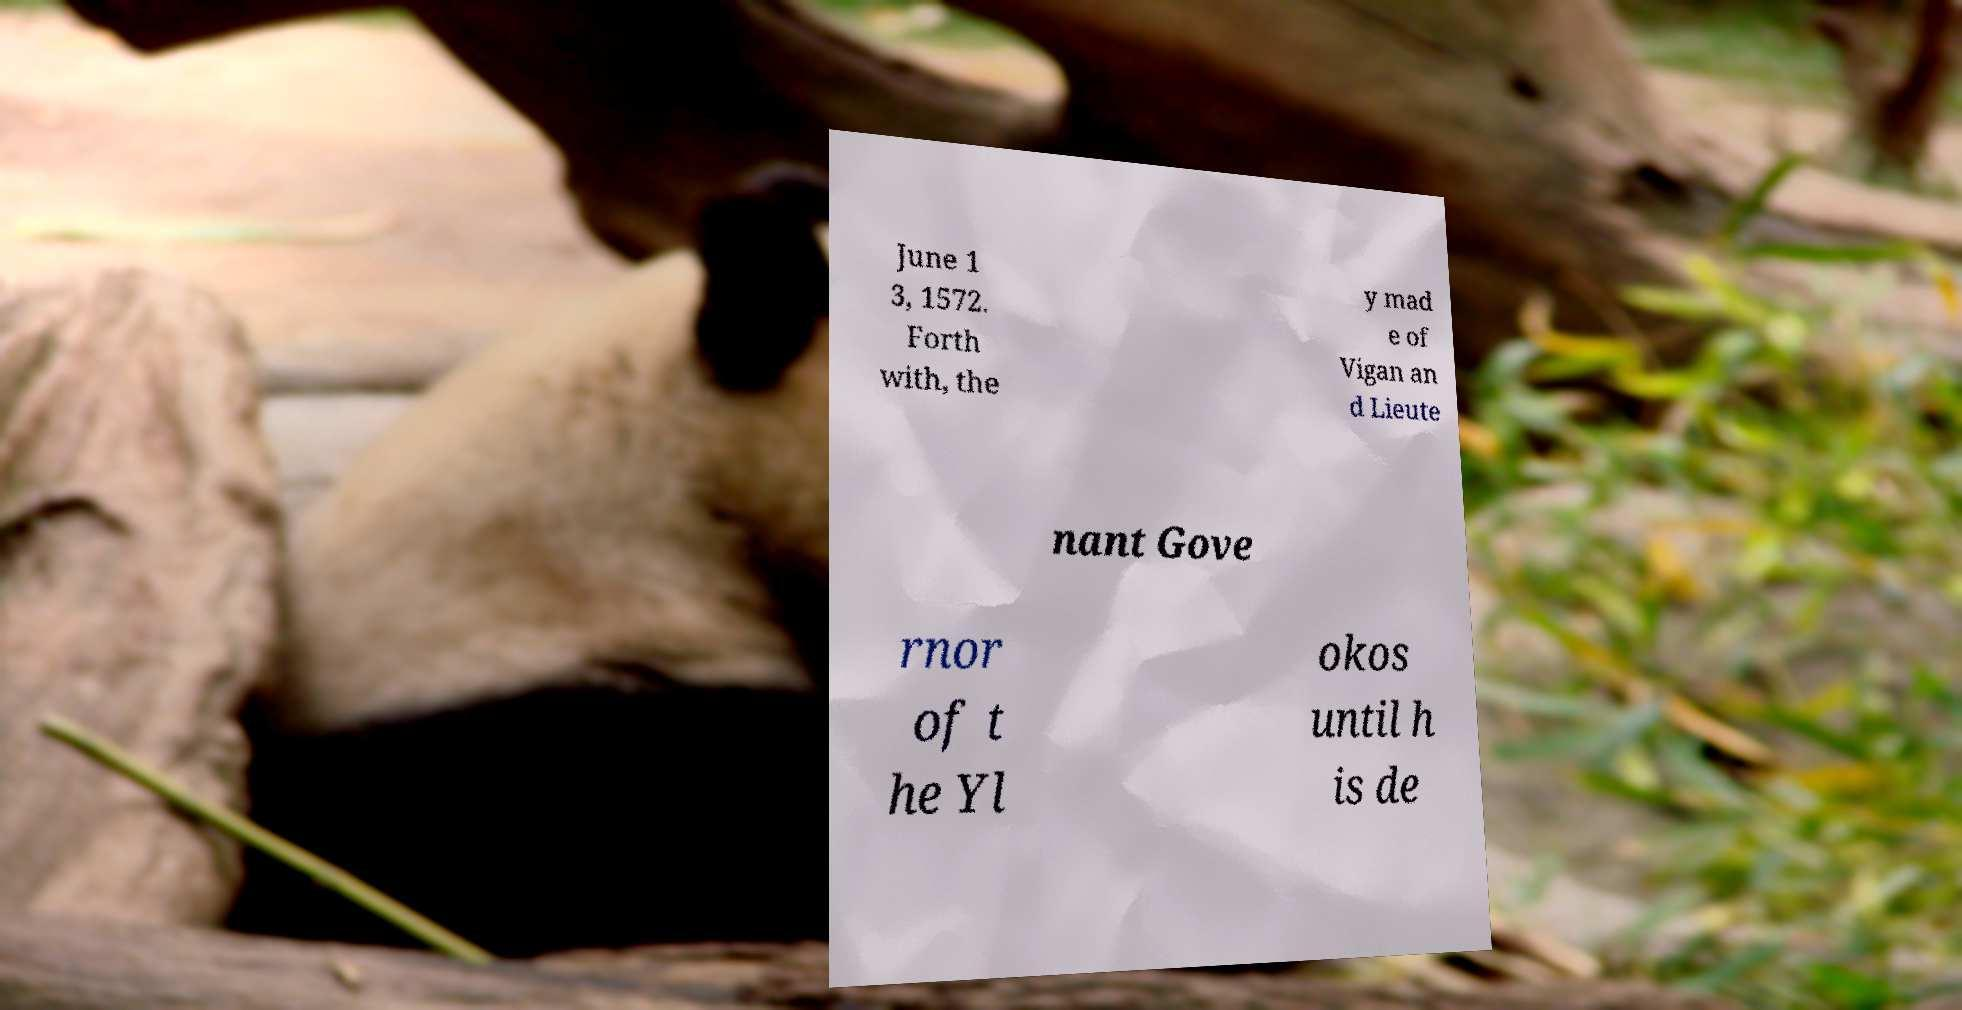There's text embedded in this image that I need extracted. Can you transcribe it verbatim? June 1 3, 1572. Forth with, the y mad e of Vigan an d Lieute nant Gove rnor of t he Yl okos until h is de 